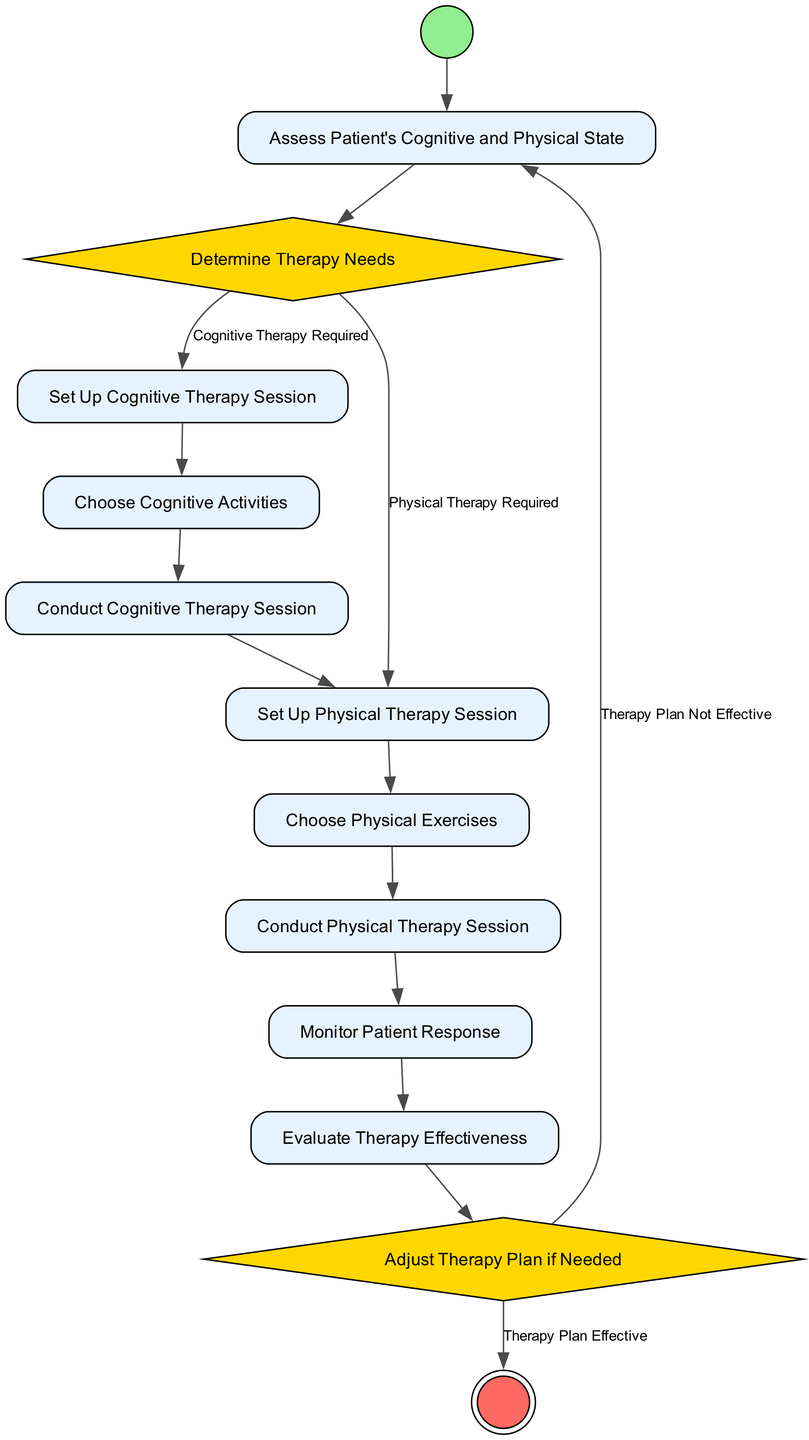What is the first activity in the diagram? The first activity is identified as the "Start" node, marked as the initial node of the diagram.
Answer: Start How many actions are present in the diagram? The diagram contains seven actions: "Assess Patient's Cognitive and Physical State", "Set Up Cognitive Therapy Session", "Choose Cognitive Activities", "Conduct Cognitive Therapy Session", "Set Up Physical Therapy Session", "Choose Physical Exercises", and "Conduct Physical Therapy Session". Counting these actions gives a total of seven.
Answer: Seven What decision branches from "Determine Therapy Needs"? The decision branches are based on the conditions: "Cognitive Therapy Required" leading to "Set Up Cognitive Therapy Session" and "Physical Therapy Required" leading to "Set Up Physical Therapy Session".
Answer: Cognitive Therapy Required, Physical Therapy Required What happens if the therapy plan is not effective? If the therapy plan is not effective, the flow goes back to "Assess Patient's Cognitive and Physical State" to reassess the patient.
Answer: Assess Patient's Cognitive and Physical State Is there an activity that leads directly to the "End" node? Yes, the "Evaluate Therapy Effectiveness" action can lead directly to the "End" node if the therapy plan is effective.
Answer: Yes What is the last action before reaching the "End" node? The last action before reaching the "End" node, contingent upon the therapy plan being effective, is "Evaluate Therapy Effectiveness".
Answer: Evaluate Therapy Effectiveness Which activities precede "Conduct Cognitive Therapy Session"? The activities that precede "Conduct Cognitive Therapy Session" are "Set Up Cognitive Therapy Session" and "Choose Cognitive Activities".
Answer: Set Up Cognitive Therapy Session, Choose Cognitive Activities In the decision "Adjust Therapy Plan if Needed", what is the condition to move to the "End"? The condition to move to the "End" is that the "Therapy Plan Effective".
Answer: Therapy Plan Effective 